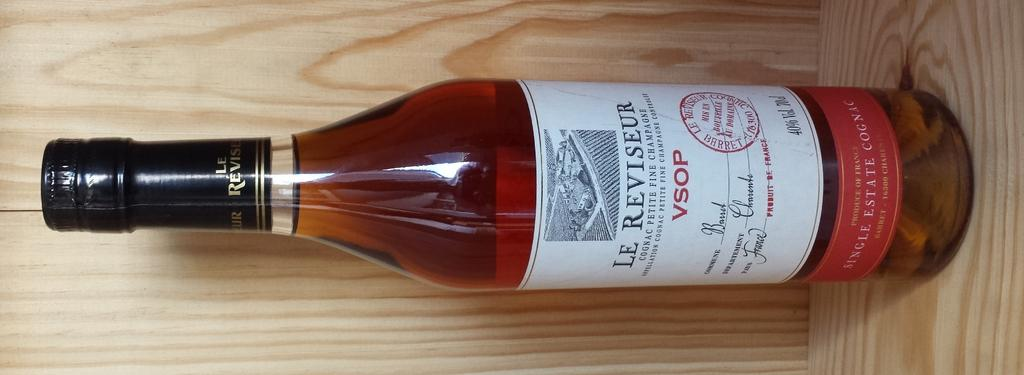<image>
Describe the image concisely. The bottle of liquid has VSOP and Le REViseur on it and it's full. 